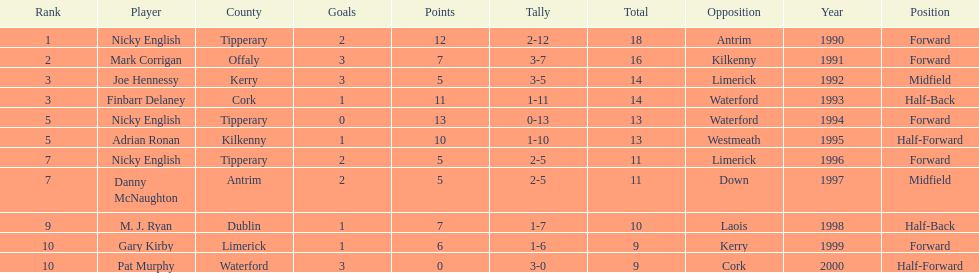Which player ranked the most? Nicky English. 